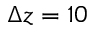<formula> <loc_0><loc_0><loc_500><loc_500>\Delta z = 1 0</formula> 